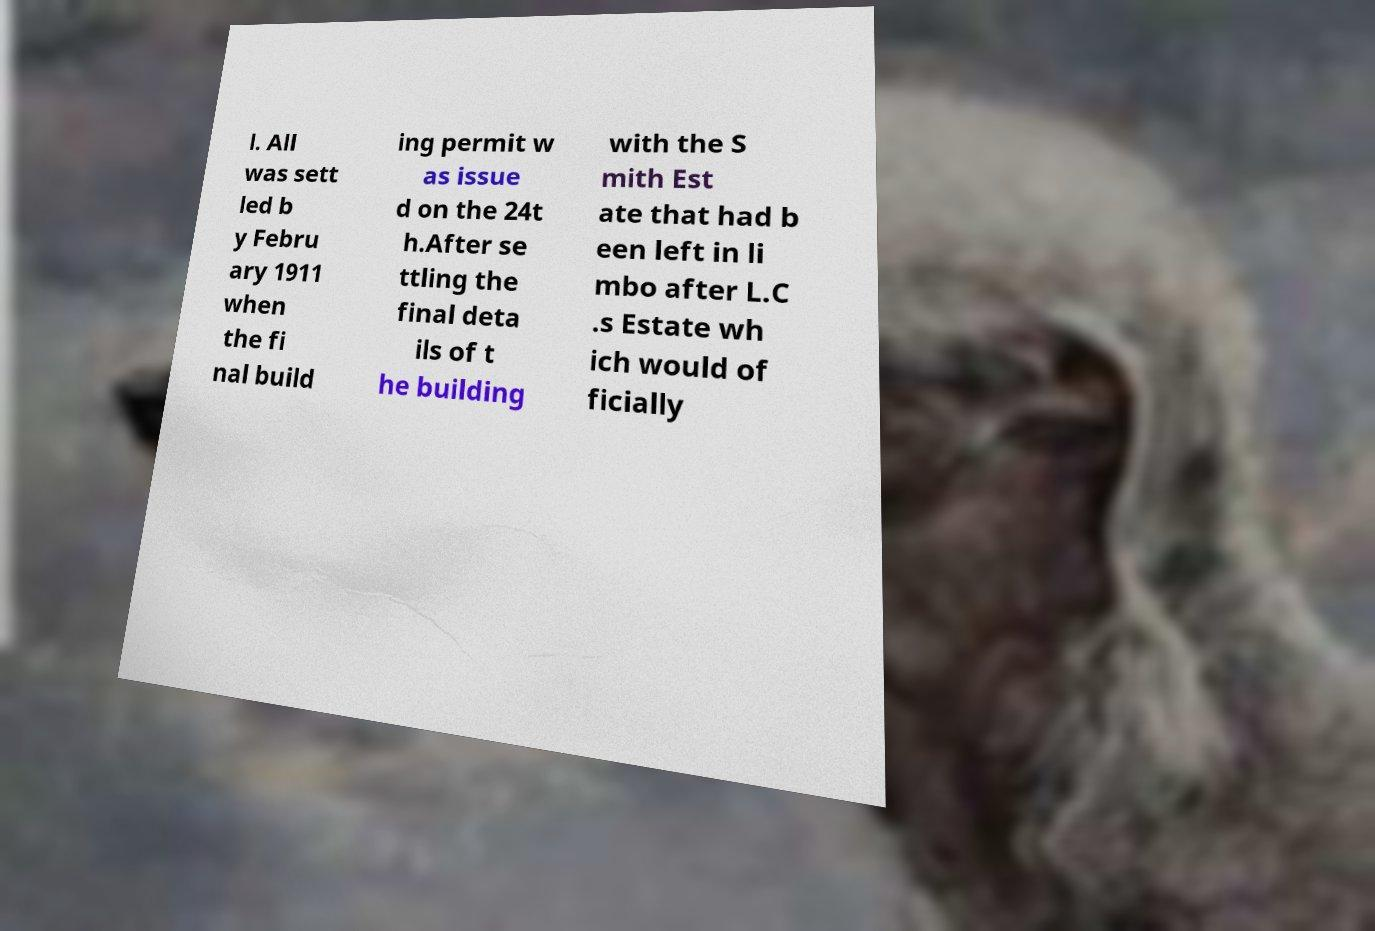Could you assist in decoding the text presented in this image and type it out clearly? l. All was sett led b y Febru ary 1911 when the fi nal build ing permit w as issue d on the 24t h.After se ttling the final deta ils of t he building with the S mith Est ate that had b een left in li mbo after L.C .s Estate wh ich would of ficially 